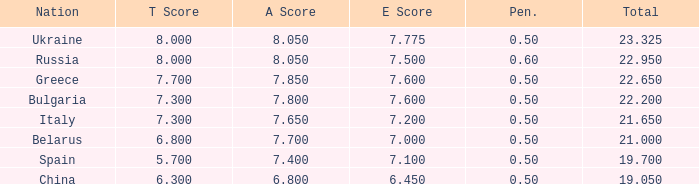With a t score of 8 and a number below 22.95, what would be the corresponding e score? None. 